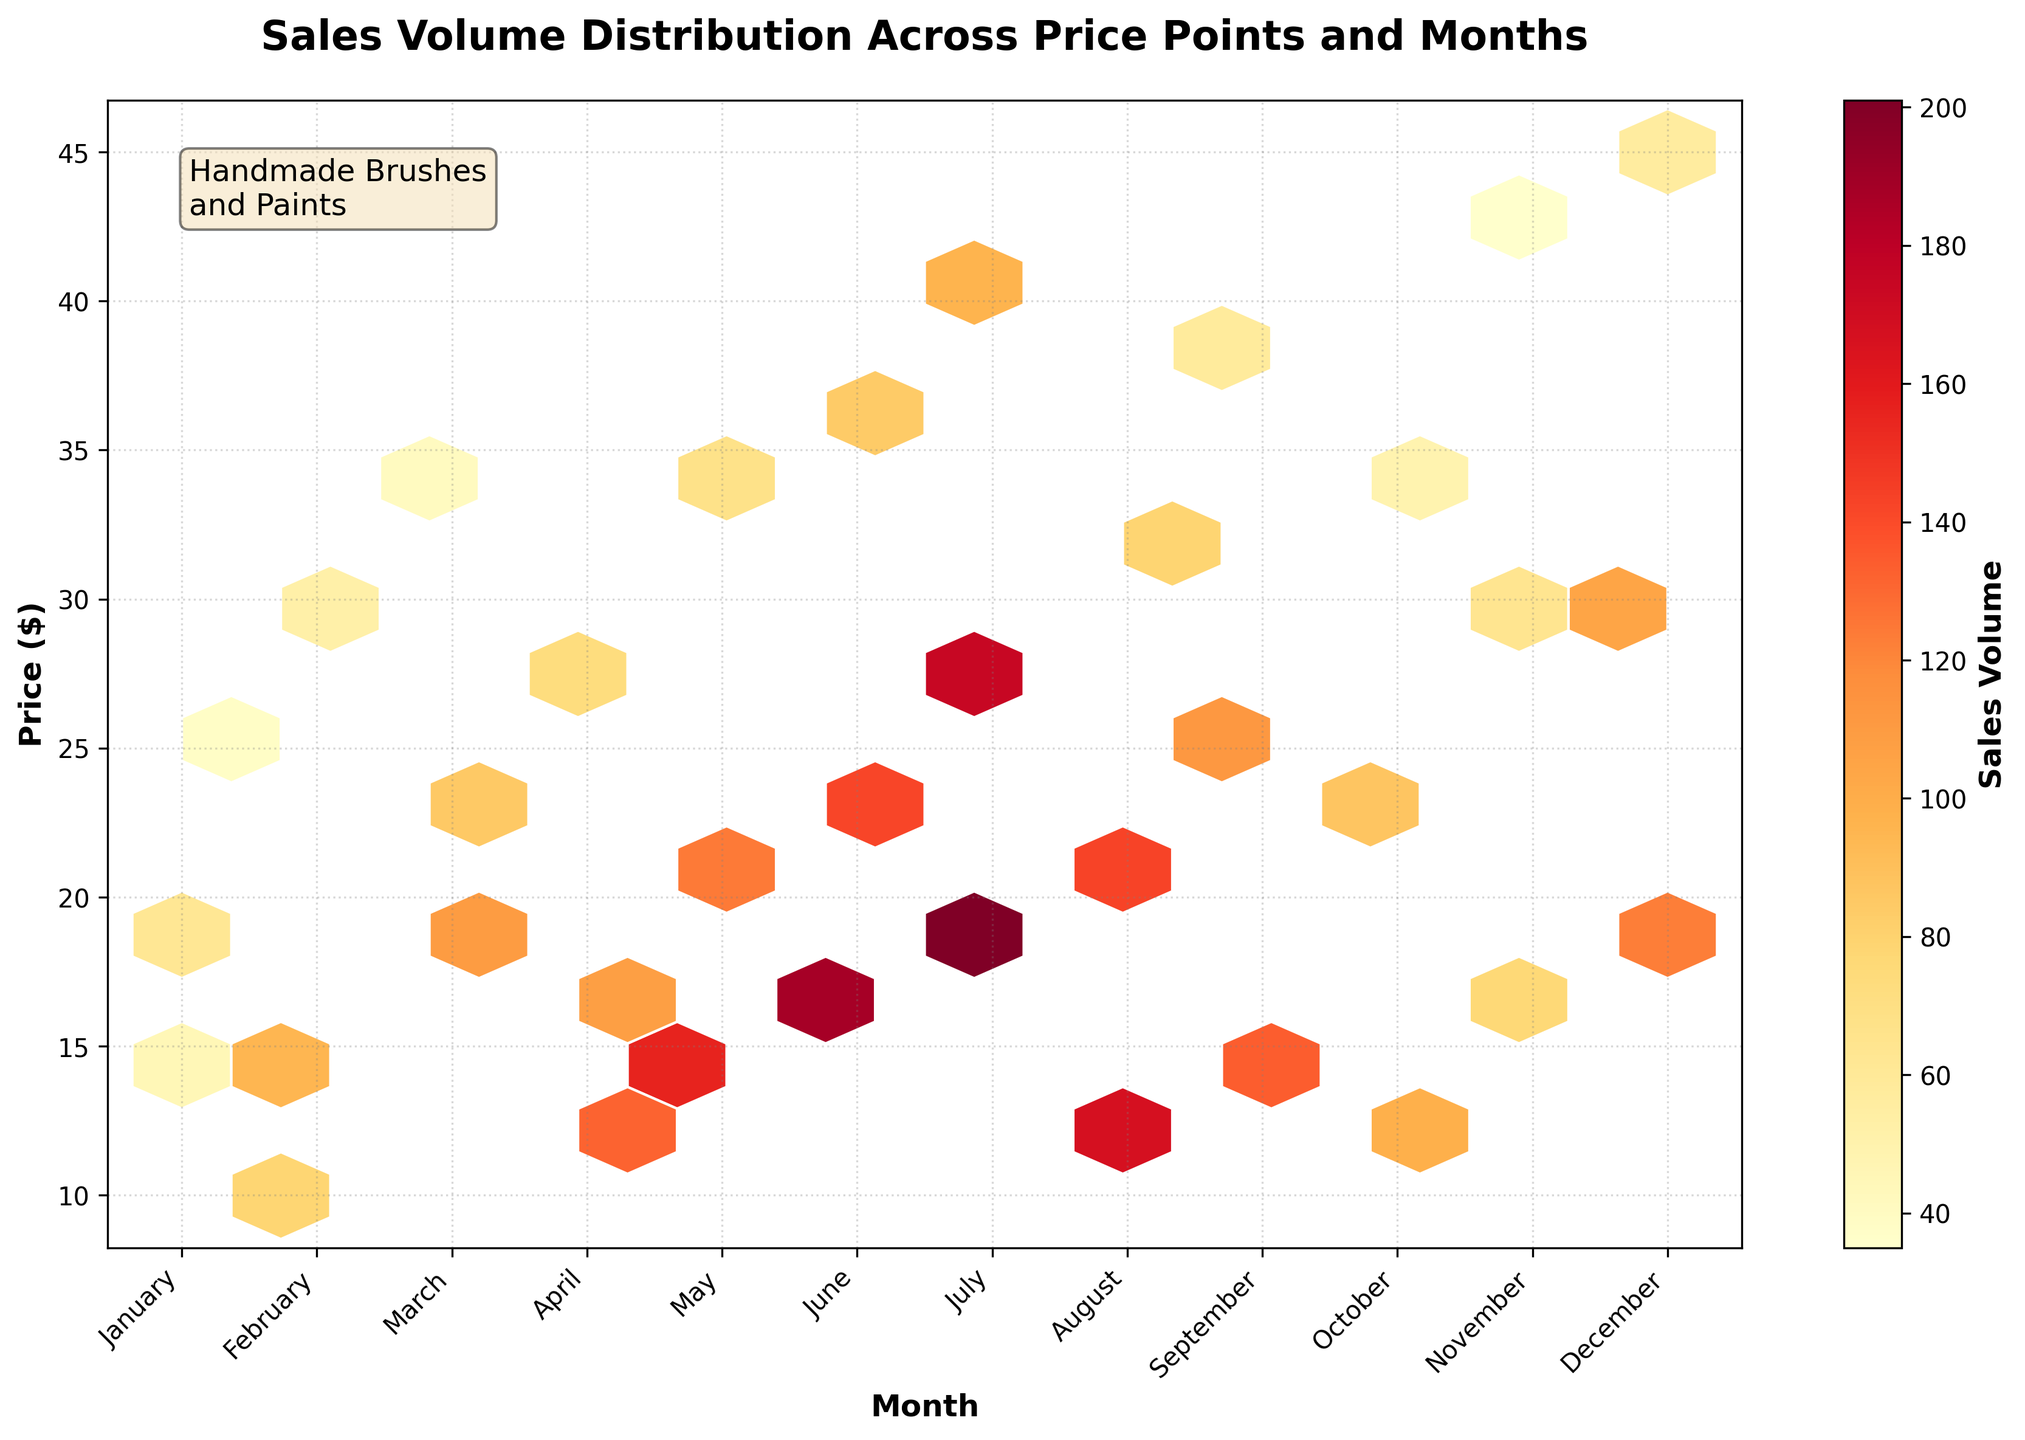What is the title of the plot? The title of the plot is displayed at the top and is usually the most prominent text. It reads: "Sales Volume Distribution Across Price Points and Months".
Answer: Sales Volume Distribution Across Price Points and Months How is sales volume represented in the plot? The sales volume is represented by color intensity within the hexagonal bins in the plot. Warmer colors (like yellow and red) indicate higher sales volumes.
Answer: Color intensity in hexagonal bins Which month shows the highest sales volume for the $10.99 price point? Locate the hexagonal bin at the intersection of the price $10.99 and the labeled month. The most intense warm color appears in August.
Answer: August What is the price point with the highest sales in June? Identify the month of June on the x-axis and find the hexagonal bin with the highest color intensity (usually red or dark orange) vertically. This occurs at the $23.99 price point.
Answer: $23.99 How does the sales volume for brushes at $29.99 change from January to December? Find the price point $29.99 and compare the color intensities of the hexagonal bins from January to December. January is lighter; December is more intense, indicating an increase.
Answer: Increased Which month has the highest overall sales volume? Observe which month has the most hexagonal bins with high color intensity collectively. July has the highest frequency of warmer colors.
Answer: July What color represents the lowest sales volumes? By examining the color bar, identify the color that corresponds to the lowest sales values. These are usually the darkest colors or colors closer to yellow.
Answer: Yellow Is there any month where sales volume for $44.99 brushes exceeds $50? Locate the $44.99 price point and observe the months with corresponding hexagonal bins. December has significant color intensity for $44.99, indicating sales exceed $50.
Answer: Yes Which price range had consistent high sales volumes across multiple months? Look for a vertical cluster of hexagonal bins with consistent warm colors across multiple months. The $15.99 - $18.99 price range shows consistent high sales across various months.
Answer: $15.99 - $18.99 Between $19.99 and $22.99 price points, which has higher sales volume in December? Compare the color intensities of the hexagonal bins for the $19.99 and $22.99 price points in December. The $19.99 bin is more intense, indicating higher sales.
Answer: $19.99 